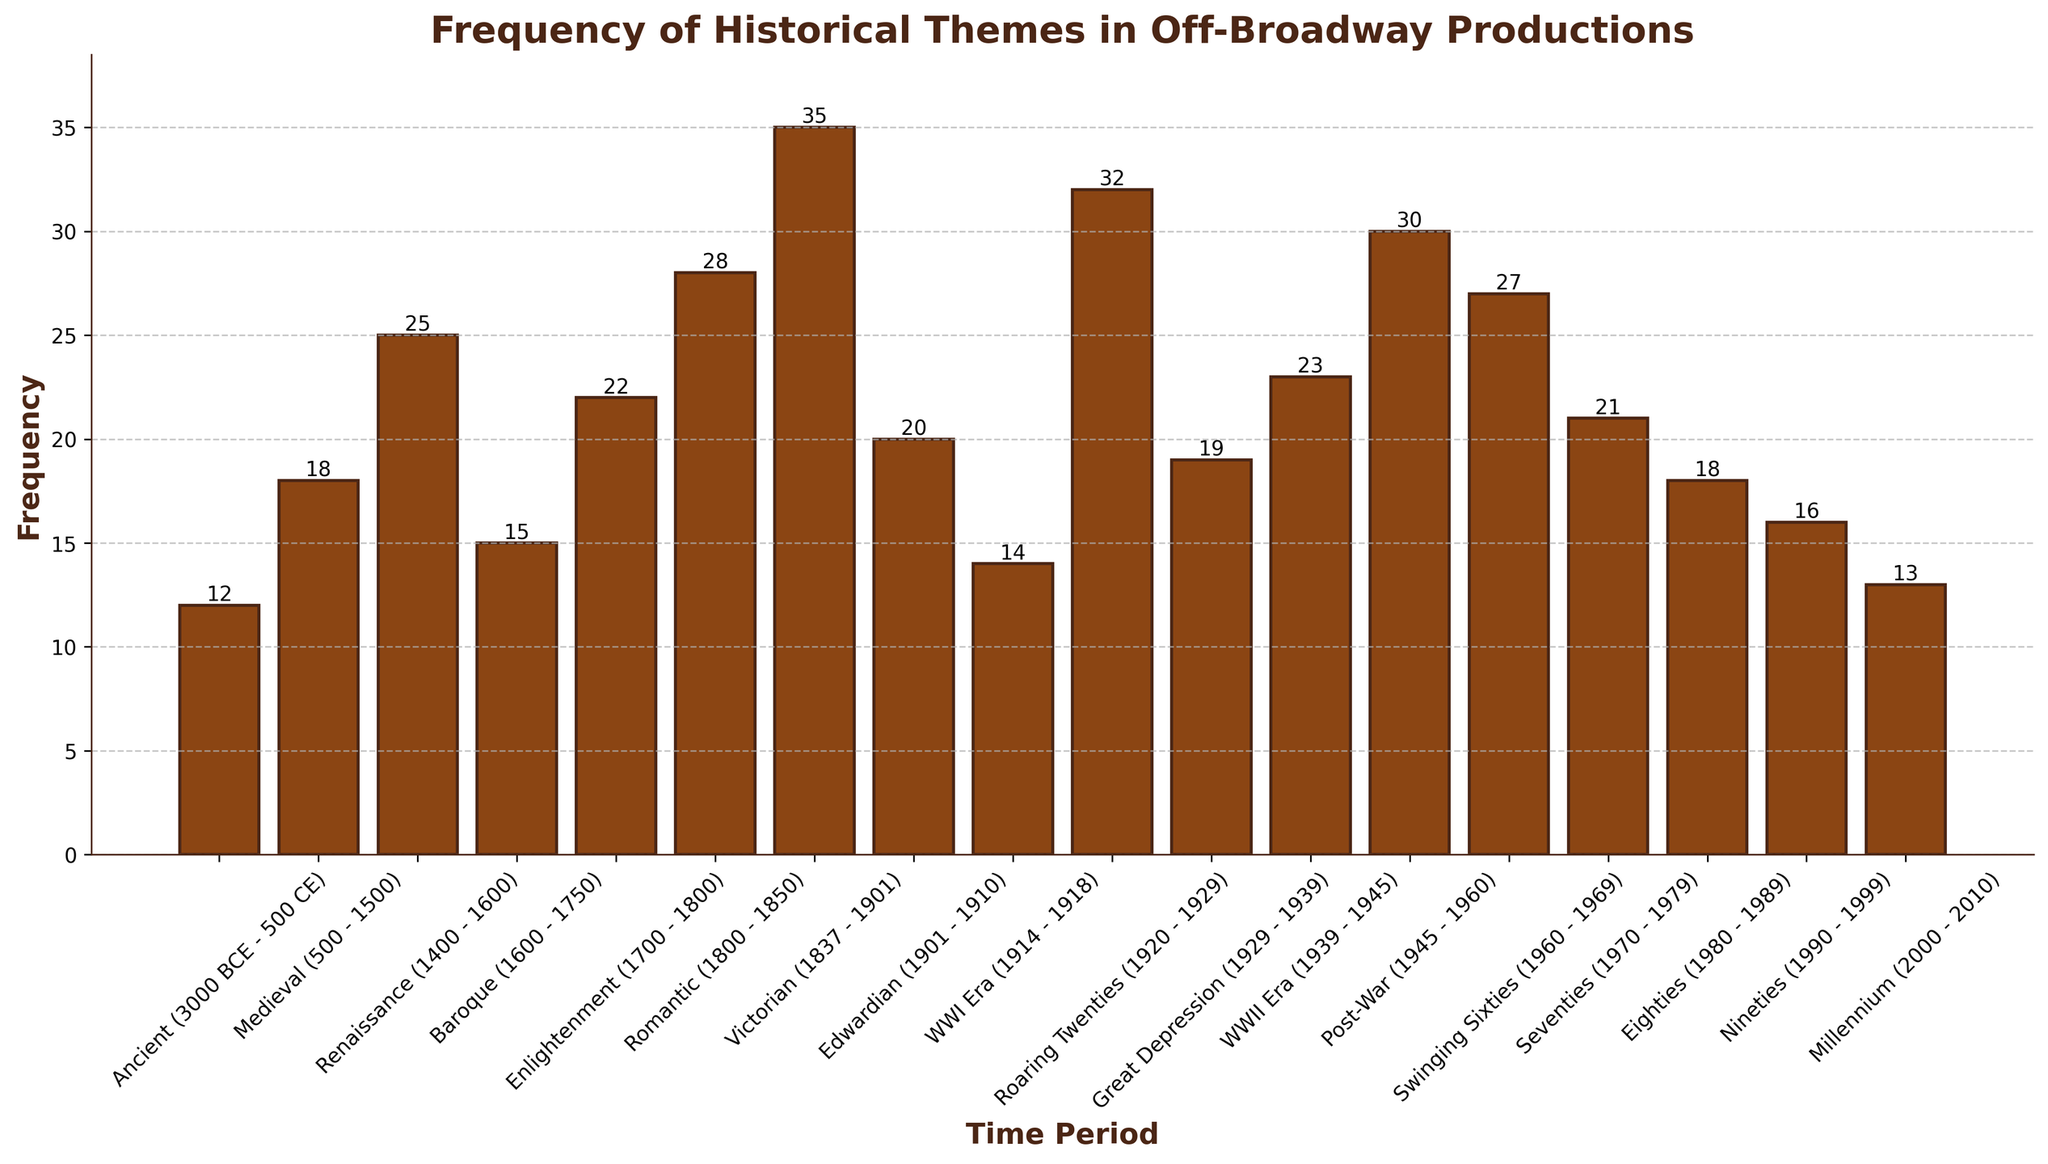Which time period has the highest frequency of historical themes in off-Broadway productions? The bar representing the Victorian period is the tallest, indicating the highest frequency.
Answer: Victorian (1837 - 1901) What is the combined frequency of the Renaissance and Enlightenment periods? The frequency of the Renaissance period is 25, and the frequency of the Enlightenment period is 22. Adding them together gives 25+22=47.
Answer: 47 Compare the frequency of themes in the Edwardian period with the Roaring Twenties. Which is higher and by how much? The frequency of the Edwardian period is 20 and the Roaring Twenties is 32. Subtracting the smaller value from the larger value gives 32-20=12.
Answer: Roaring Twenties by 12 Is the frequency of the Post-War period greater than or equal to the combined frequencies of the Eighties and Nineties periods? The frequency of the Post-War period is 30. The combined frequency of the Eighties (18) and Nineties (16) is 18+16=34. Since 30 is less than 34, the answer is no.
Answer: No What is the average frequency of the Ancient, Medieval, and Seventies periods? Summing the frequencies: Ancient (12), Medieval (18), and Seventies (21) gives 12+18+21=51. The average is 51/3=17.
Answer: 17 Which two consecutive time periods have the smallest difference in frequency? Calculating the differences between each pair: 
Medieval and Ancient: 18-12=6
Renaissance and Medieval: 25-18=7
Baroque and Renaissance: 25-15=10
Enlightenment and Baroque: 22-15=7
Romantic and Enlightenment: 28-22=6
Victorian and Romantic: 35-28=7
Edwardian and Victorian: 35-20=15 
WWI Era and Edwardian: 20-14=6
Roaring Twenties and WWI Era: 32-14=18
Great Depression and Roaring Twenties: 32-19=13
WWII Era and Great Depression: 23-19=4
Post-War and WWII Era: 30-23=7
Swinging Sixties and Post-War: 27-30=-3 (absolute value 3) 
Seventies and Swinging Sixties: 27-21=6 
Eighties and Seventies: 21-18=3 
Nineties and Eighties: 18-16=2 
Millennium and Nineties: 16-13=3
Smallest difference (2) is between Eighties and Nineties.
Answer: Eighties and Nineties What is the median frequency value of the time periods? Arranging the frequencies in ascending order: 
12, 13, 14, 15, 16, 18, 18, 19, 20, 21, 22, 23, 25, 27, 28, 30, 32, 35. 
The median value of an ordered list of 18 numbers is the average of the 9th and 10th values:
(20+21)/2=20.5.
Answer: 20.5 What is the frequency difference between the Baroque and the Seventies periods? The frequency of the Baroque period is 15 and the Seventies period is 21. The difference is 21-15=6.
Answer: 6 